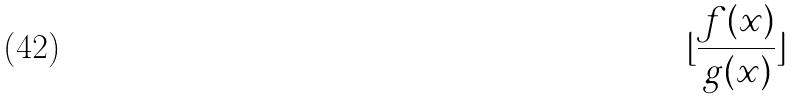Convert formula to latex. <formula><loc_0><loc_0><loc_500><loc_500>\lfloor \frac { f ( x ) } { g ( x ) } \rfloor</formula> 